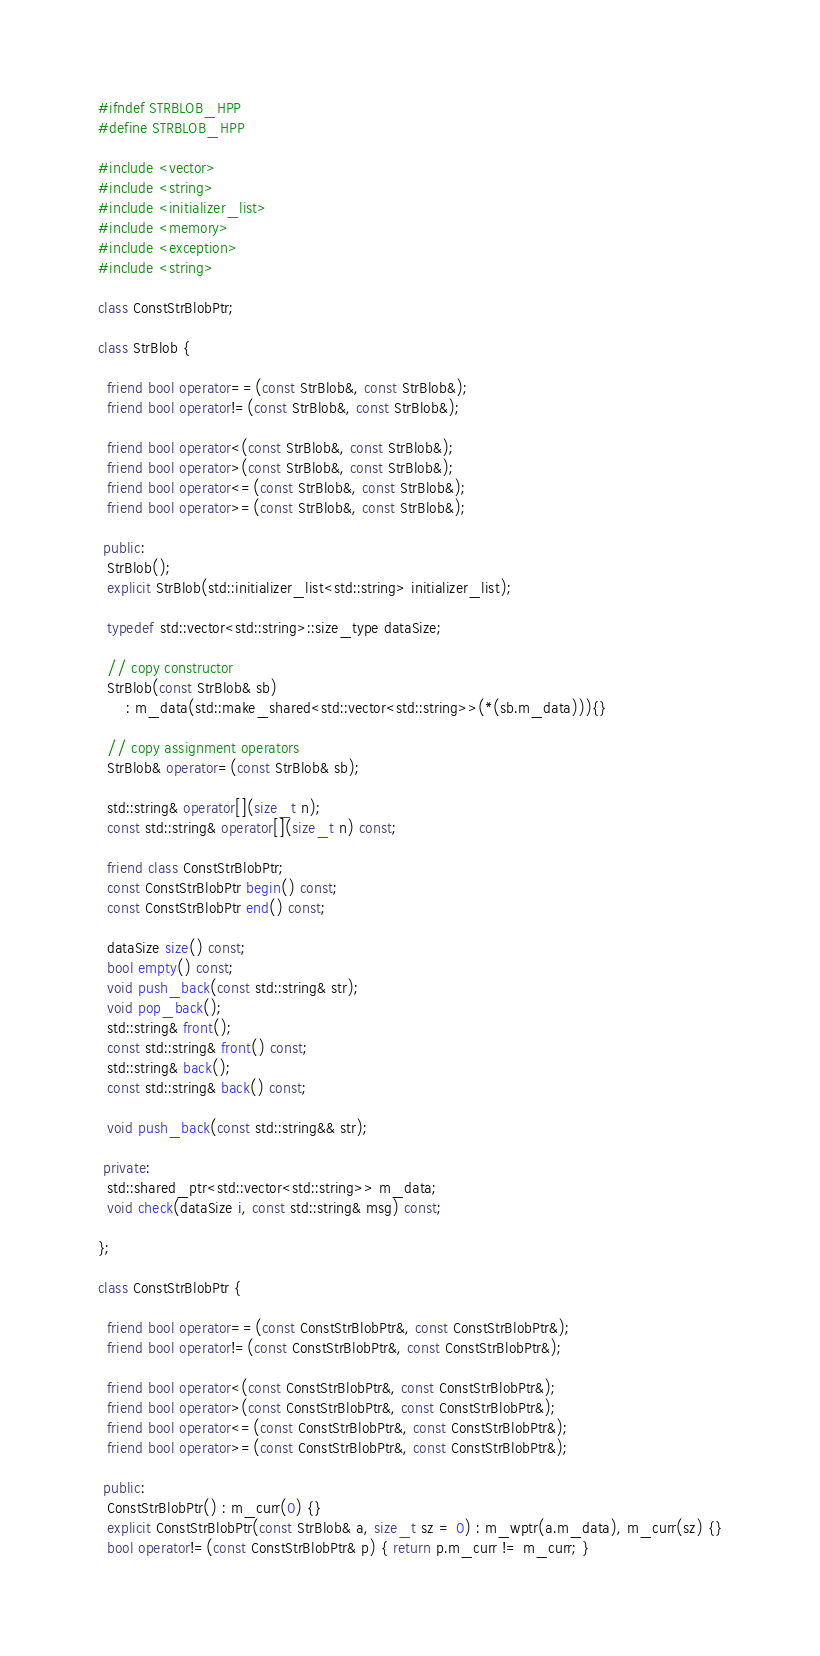Convert code to text. <code><loc_0><loc_0><loc_500><loc_500><_C++_>#ifndef STRBLOB_HPP
#define STRBLOB_HPP

#include <vector>
#include <string>
#include <initializer_list>
#include <memory>
#include <exception>
#include <string>

class ConstStrBlobPtr;

class StrBlob {

  friend bool operator==(const StrBlob&, const StrBlob&);
  friend bool operator!=(const StrBlob&, const StrBlob&);

  friend bool operator<(const StrBlob&, const StrBlob&);
  friend bool operator>(const StrBlob&, const StrBlob&);
  friend bool operator<=(const StrBlob&, const StrBlob&);
  friend bool operator>=(const StrBlob&, const StrBlob&);

 public:
  StrBlob();
  explicit StrBlob(std::initializer_list<std::string> initializer_list);

  typedef std::vector<std::string>::size_type dataSize;

  // copy constructor
  StrBlob(const StrBlob& sb)
      : m_data(std::make_shared<std::vector<std::string>>(*(sb.m_data))){}

  // copy assignment operators
  StrBlob& operator=(const StrBlob& sb);

  std::string& operator[](size_t n);
  const std::string& operator[](size_t n) const;

  friend class ConstStrBlobPtr;
  const ConstStrBlobPtr begin() const;
  const ConstStrBlobPtr end() const;

  dataSize size() const;
  bool empty() const;
  void push_back(const std::string& str);
  void pop_back();
  std::string& front();
  const std::string& front() const;
  std::string& back();
  const std::string& back() const;

  void push_back(const std::string&& str);

 private:
  std::shared_ptr<std::vector<std::string>> m_data;
  void check(dataSize i, const std::string& msg) const;

};

class ConstStrBlobPtr {

  friend bool operator==(const ConstStrBlobPtr&, const ConstStrBlobPtr&);
  friend bool operator!=(const ConstStrBlobPtr&, const ConstStrBlobPtr&);

  friend bool operator<(const ConstStrBlobPtr&, const ConstStrBlobPtr&);
  friend bool operator>(const ConstStrBlobPtr&, const ConstStrBlobPtr&);
  friend bool operator<=(const ConstStrBlobPtr&, const ConstStrBlobPtr&);
  friend bool operator>=(const ConstStrBlobPtr&, const ConstStrBlobPtr&);

 public:
  ConstStrBlobPtr() : m_curr(0) {}
  explicit ConstStrBlobPtr(const StrBlob& a, size_t sz = 0) : m_wptr(a.m_data), m_curr(sz) {}
  bool operator!=(const ConstStrBlobPtr& p) { return p.m_curr != m_curr; }
</code> 